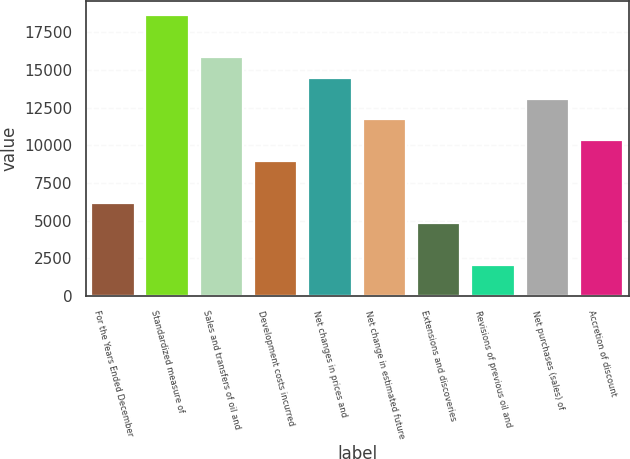<chart> <loc_0><loc_0><loc_500><loc_500><bar_chart><fcel>For the Years Ended December<fcel>Standardized measure of<fcel>Sales and transfers of oil and<fcel>Development costs incurred<fcel>Net changes in prices and<fcel>Net change in estimated future<fcel>Extensions and discoveries<fcel>Revisions of previous oil and<fcel>Net purchases (sales) of<fcel>Accretion of discount<nl><fcel>6201.8<fcel>18632.6<fcel>15870.2<fcel>8964.2<fcel>14489<fcel>11726.6<fcel>4820.6<fcel>2058.2<fcel>13107.8<fcel>10345.4<nl></chart> 